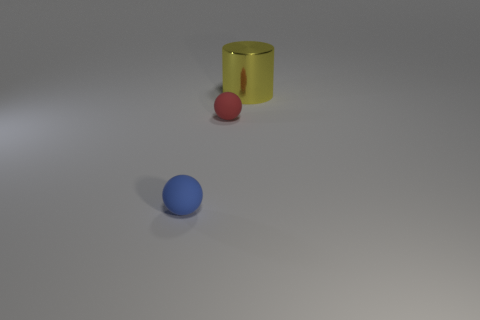Add 2 big metallic cylinders. How many objects exist? 5 Subtract all spheres. How many objects are left? 1 Add 2 matte spheres. How many matte spheres exist? 4 Subtract 0 cyan cylinders. How many objects are left? 3 Subtract all large gray metallic balls. Subtract all tiny blue matte spheres. How many objects are left? 2 Add 3 small blue rubber things. How many small blue rubber things are left? 4 